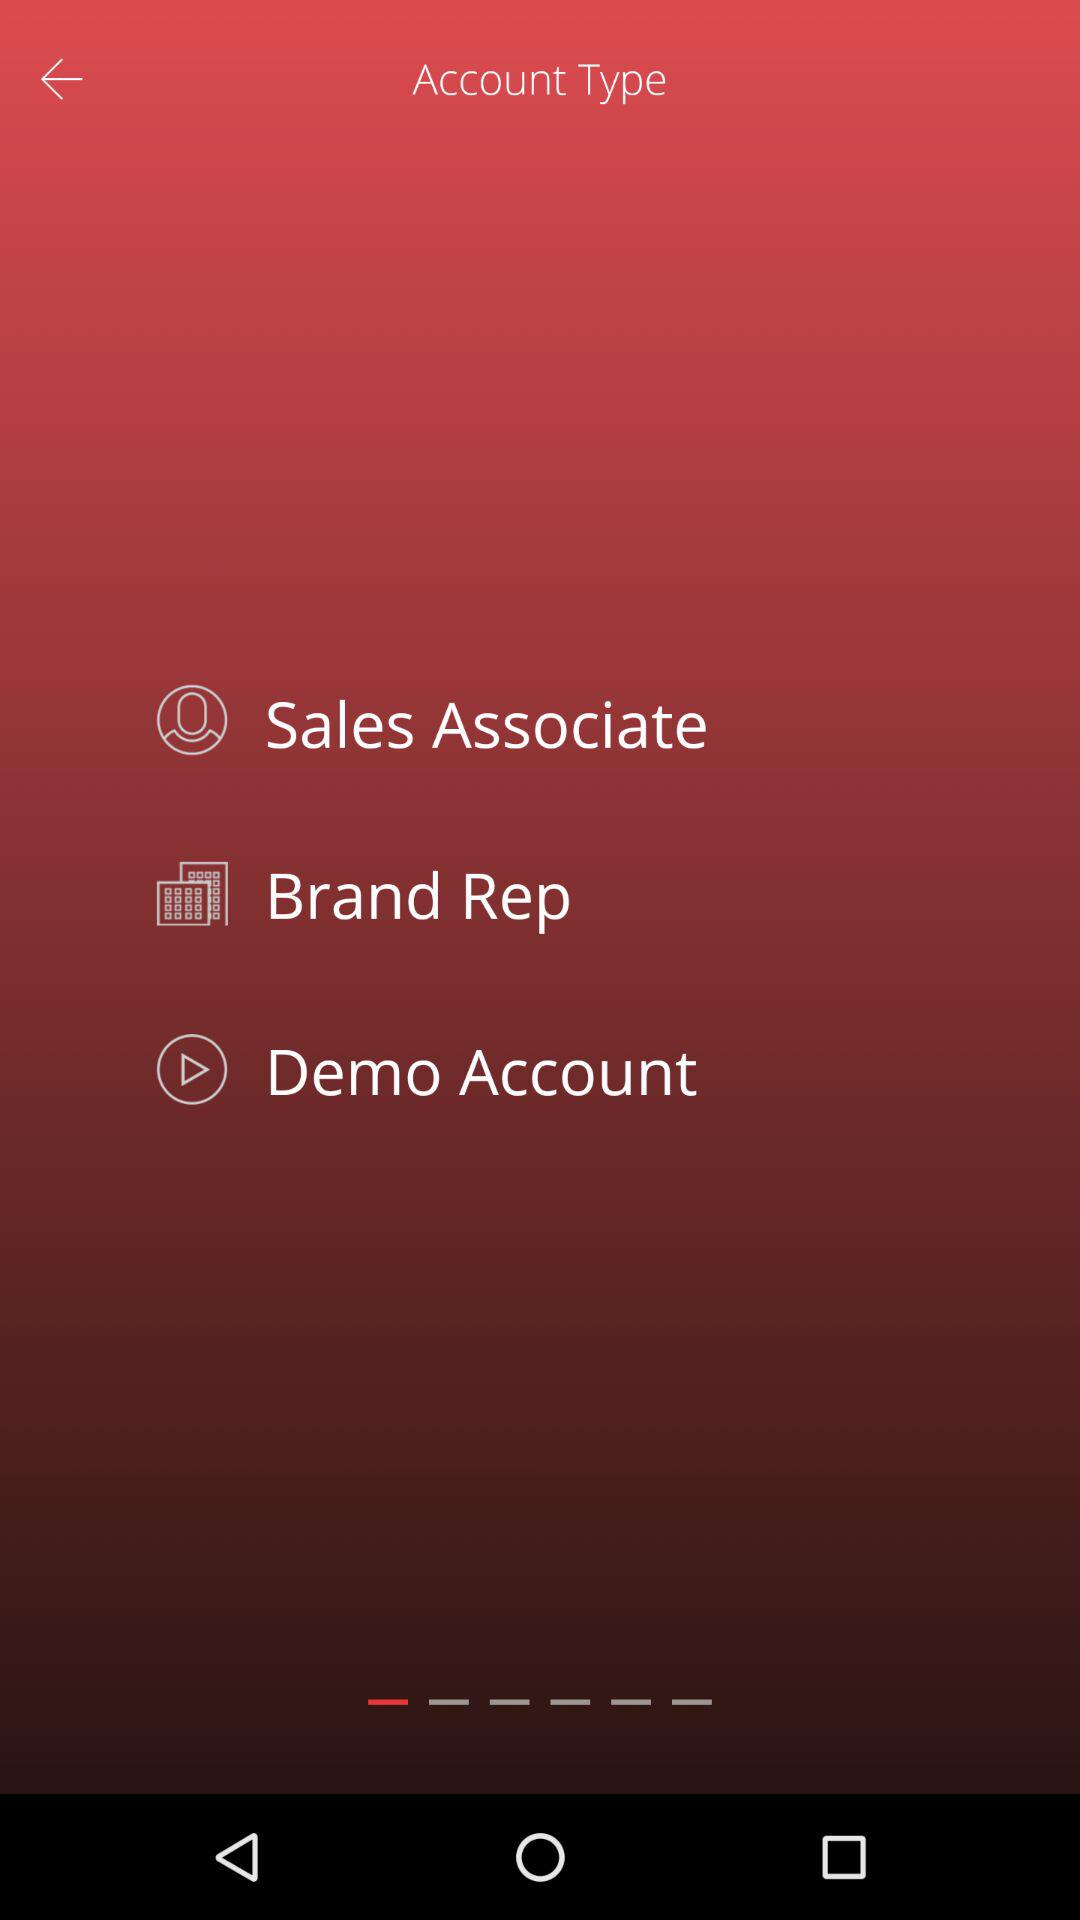How many account types are there?
Answer the question using a single word or phrase. 3 